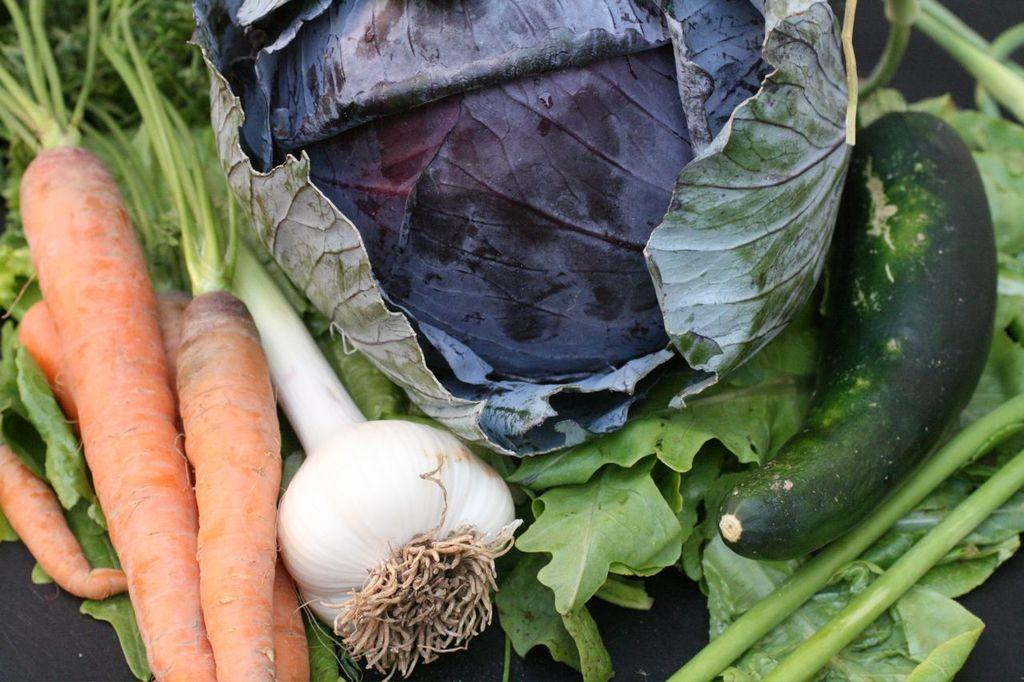What type of vegetables can be seen in the image? Carrots, garlic, cabbage, and cucumbers can be seen in the image. What else is present in the image besides vegetables? There are leaves in the image. Where are these items placed? All of these items are placed on a surface. What type of mist can be seen surrounding the ship in the image? There is no ship or mist present in the image; it features vegetables and leaves on a surface. 